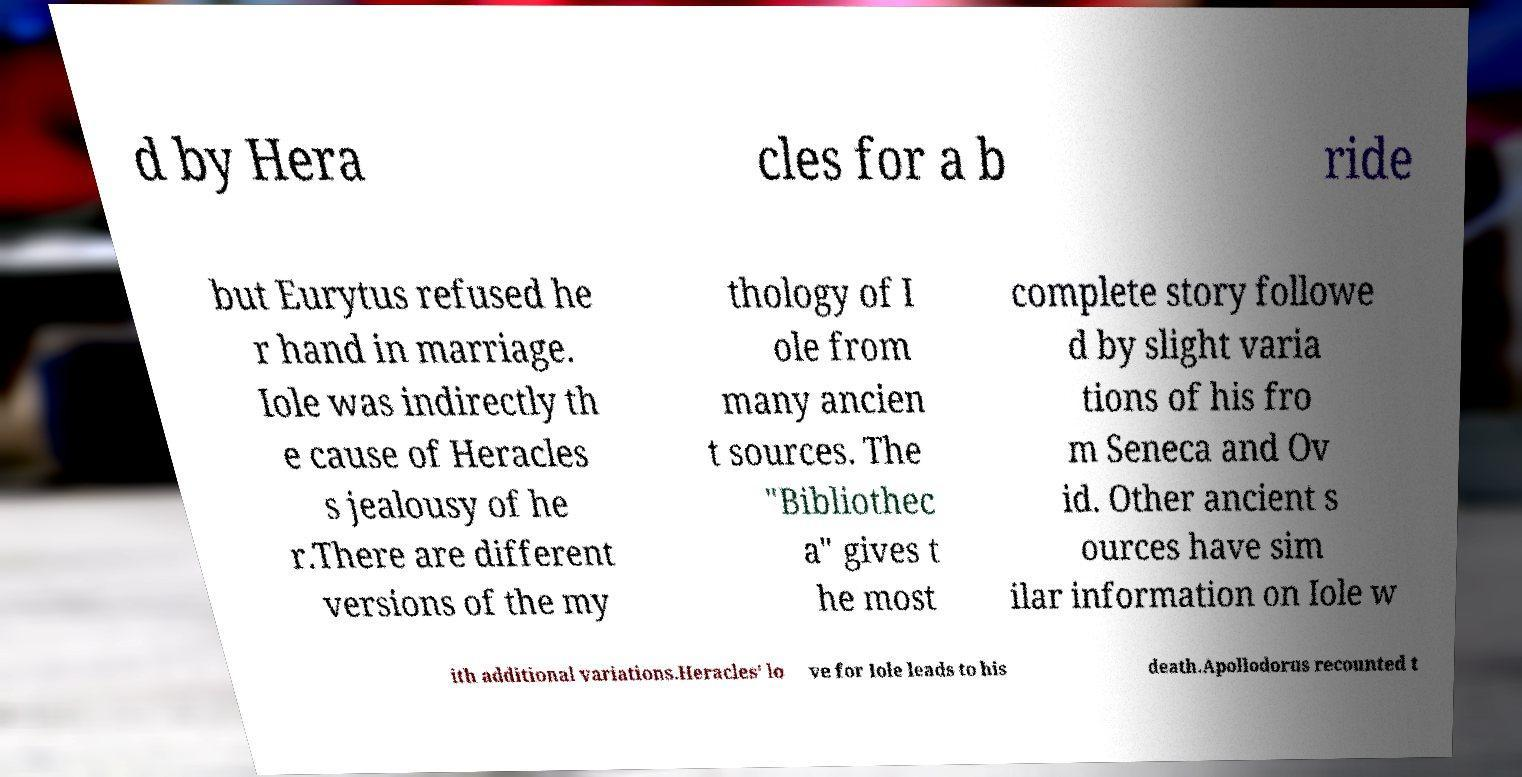For documentation purposes, I need the text within this image transcribed. Could you provide that? d by Hera cles for a b ride but Eurytus refused he r hand in marriage. Iole was indirectly th e cause of Heracles s jealousy of he r.There are different versions of the my thology of I ole from many ancien t sources. The "Bibliothec a" gives t he most complete story followe d by slight varia tions of his fro m Seneca and Ov id. Other ancient s ources have sim ilar information on Iole w ith additional variations.Heracles' lo ve for Iole leads to his death.Apollodorus recounted t 